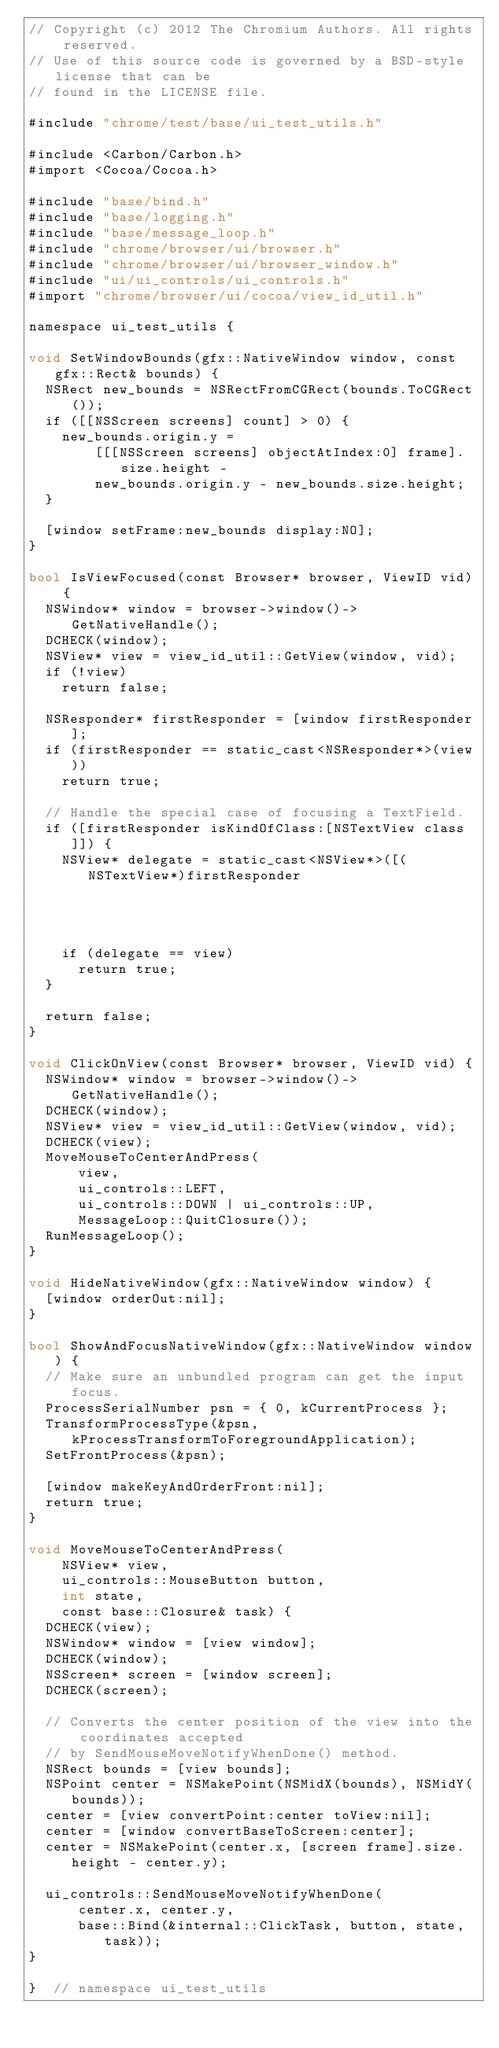<code> <loc_0><loc_0><loc_500><loc_500><_ObjectiveC_>// Copyright (c) 2012 The Chromium Authors. All rights reserved.
// Use of this source code is governed by a BSD-style license that can be
// found in the LICENSE file.

#include "chrome/test/base/ui_test_utils.h"

#include <Carbon/Carbon.h>
#import <Cocoa/Cocoa.h>

#include "base/bind.h"
#include "base/logging.h"
#include "base/message_loop.h"
#include "chrome/browser/ui/browser.h"
#include "chrome/browser/ui/browser_window.h"
#include "ui/ui_controls/ui_controls.h"
#import "chrome/browser/ui/cocoa/view_id_util.h"

namespace ui_test_utils {

void SetWindowBounds(gfx::NativeWindow window, const gfx::Rect& bounds) {
  NSRect new_bounds = NSRectFromCGRect(bounds.ToCGRect());
  if ([[NSScreen screens] count] > 0) {
    new_bounds.origin.y =
        [[[NSScreen screens] objectAtIndex:0] frame].size.height -
        new_bounds.origin.y - new_bounds.size.height;
  }

  [window setFrame:new_bounds display:NO];
}

bool IsViewFocused(const Browser* browser, ViewID vid) {
  NSWindow* window = browser->window()->GetNativeHandle();
  DCHECK(window);
  NSView* view = view_id_util::GetView(window, vid);
  if (!view)
    return false;

  NSResponder* firstResponder = [window firstResponder];
  if (firstResponder == static_cast<NSResponder*>(view))
    return true;

  // Handle the special case of focusing a TextField.
  if ([firstResponder isKindOfClass:[NSTextView class]]) {
    NSView* delegate = static_cast<NSView*>([(NSTextView*)firstResponder
                                                          delegate]);
    if (delegate == view)
      return true;
  }

  return false;
}

void ClickOnView(const Browser* browser, ViewID vid) {
  NSWindow* window = browser->window()->GetNativeHandle();
  DCHECK(window);
  NSView* view = view_id_util::GetView(window, vid);
  DCHECK(view);
  MoveMouseToCenterAndPress(
      view,
      ui_controls::LEFT,
      ui_controls::DOWN | ui_controls::UP,
      MessageLoop::QuitClosure());
  RunMessageLoop();
}

void HideNativeWindow(gfx::NativeWindow window) {
  [window orderOut:nil];
}

bool ShowAndFocusNativeWindow(gfx::NativeWindow window) {
  // Make sure an unbundled program can get the input focus.
  ProcessSerialNumber psn = { 0, kCurrentProcess };
  TransformProcessType(&psn,kProcessTransformToForegroundApplication);
  SetFrontProcess(&psn);

  [window makeKeyAndOrderFront:nil];
  return true;
}

void MoveMouseToCenterAndPress(
    NSView* view,
    ui_controls::MouseButton button,
    int state,
    const base::Closure& task) {
  DCHECK(view);
  NSWindow* window = [view window];
  DCHECK(window);
  NSScreen* screen = [window screen];
  DCHECK(screen);

  // Converts the center position of the view into the coordinates accepted
  // by SendMouseMoveNotifyWhenDone() method.
  NSRect bounds = [view bounds];
  NSPoint center = NSMakePoint(NSMidX(bounds), NSMidY(bounds));
  center = [view convertPoint:center toView:nil];
  center = [window convertBaseToScreen:center];
  center = NSMakePoint(center.x, [screen frame].size.height - center.y);

  ui_controls::SendMouseMoveNotifyWhenDone(
      center.x, center.y,
      base::Bind(&internal::ClickTask, button, state, task));
}

}  // namespace ui_test_utils
</code> 